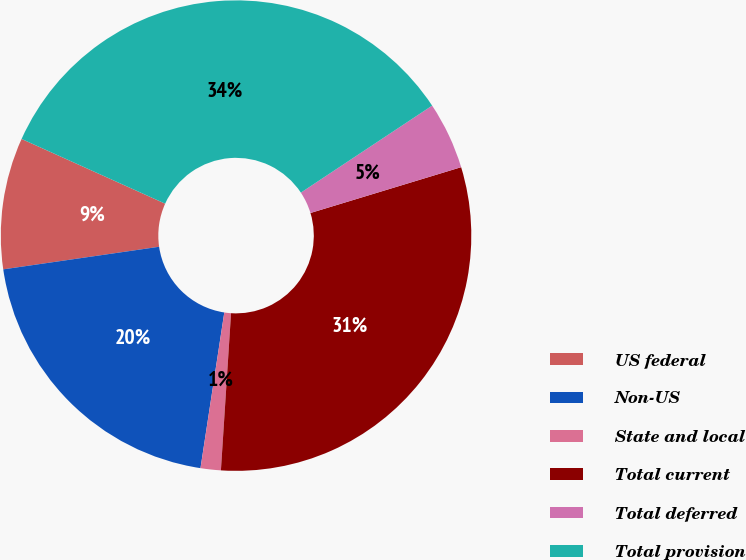Convert chart to OTSL. <chart><loc_0><loc_0><loc_500><loc_500><pie_chart><fcel>US federal<fcel>Non-US<fcel>State and local<fcel>Total current<fcel>Total deferred<fcel>Total provision<nl><fcel>9.03%<fcel>20.29%<fcel>1.39%<fcel>30.72%<fcel>4.62%<fcel>33.94%<nl></chart> 